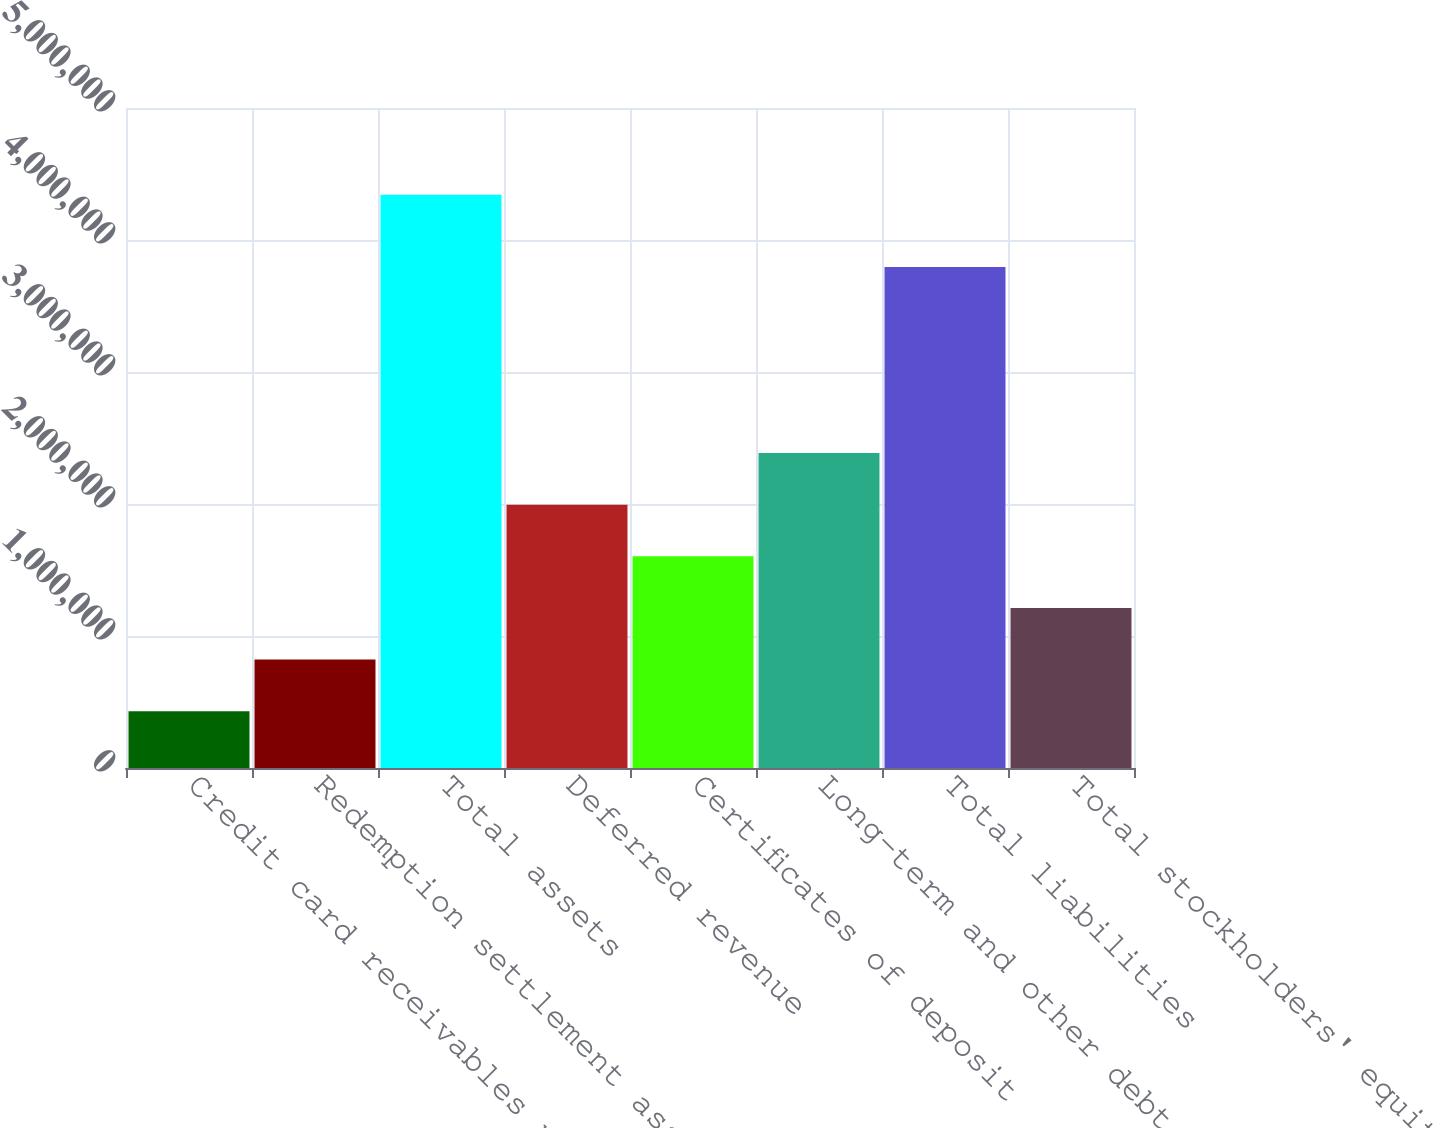<chart> <loc_0><loc_0><loc_500><loc_500><bar_chart><fcel>Credit card receivables net<fcel>Redemption settlement assets<fcel>Total assets<fcel>Deferred revenue<fcel>Certificates of deposit<fcel>Long-term and other debt<fcel>Total liabilities<fcel>Total stockholders' equity<nl><fcel>430512<fcel>821660<fcel>4.34199e+06<fcel>1.9951e+06<fcel>1.60396e+06<fcel>2.38625e+06<fcel>3.79469e+06<fcel>1.21281e+06<nl></chart> 